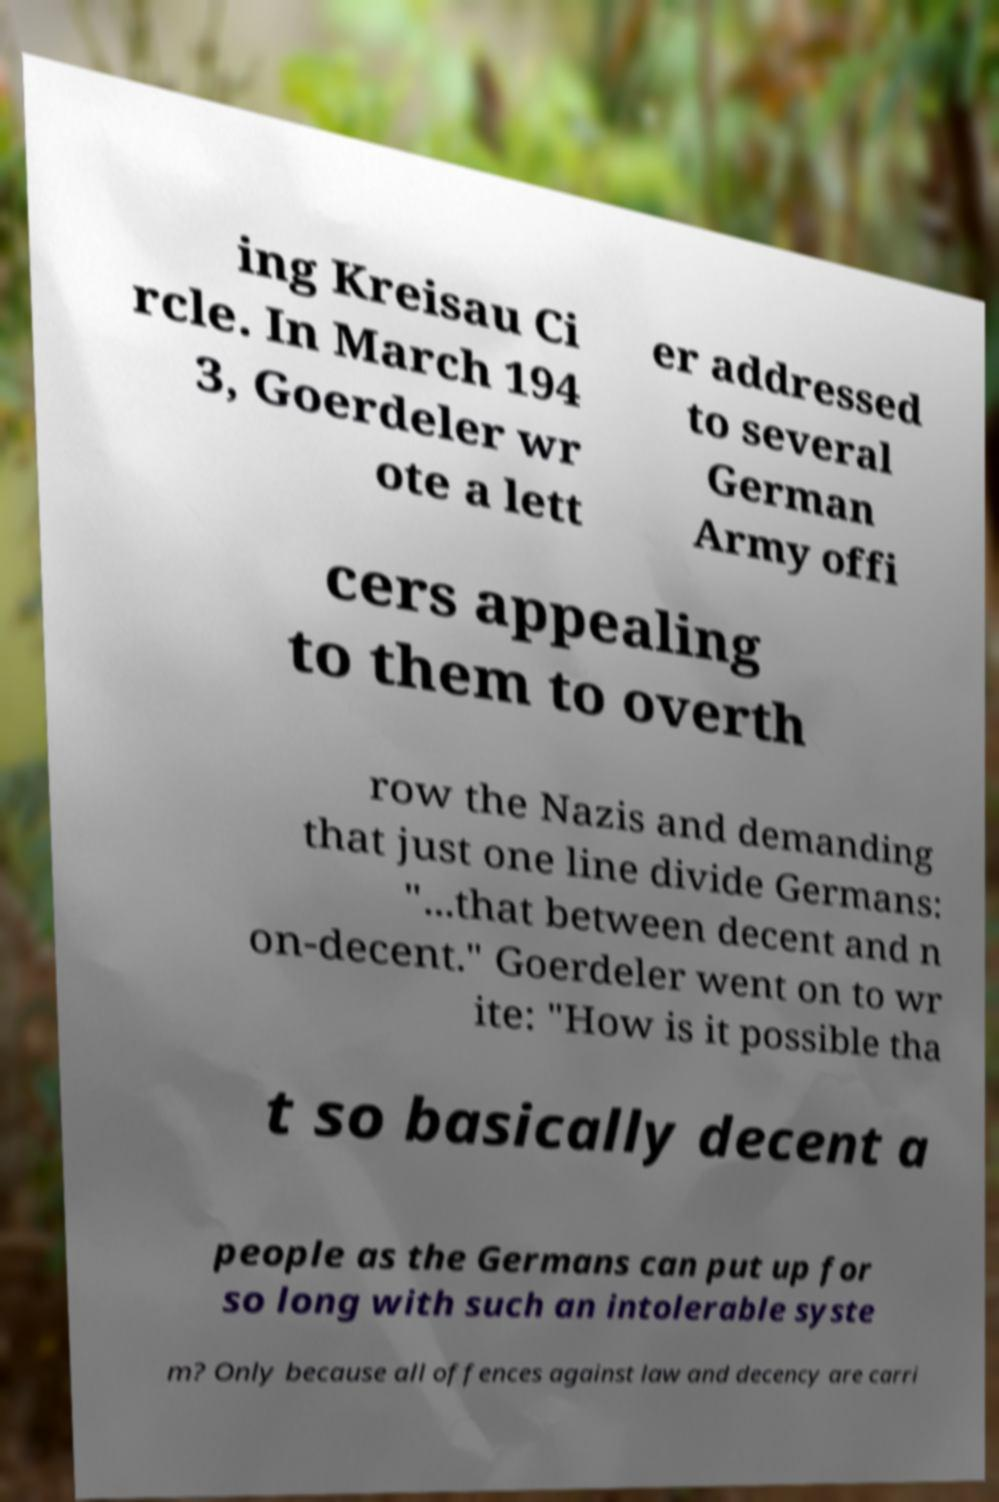Could you assist in decoding the text presented in this image and type it out clearly? ing Kreisau Ci rcle. In March 194 3, Goerdeler wr ote a lett er addressed to several German Army offi cers appealing to them to overth row the Nazis and demanding that just one line divide Germans: "...that between decent and n on-decent." Goerdeler went on to wr ite: "How is it possible tha t so basically decent a people as the Germans can put up for so long with such an intolerable syste m? Only because all offences against law and decency are carri 